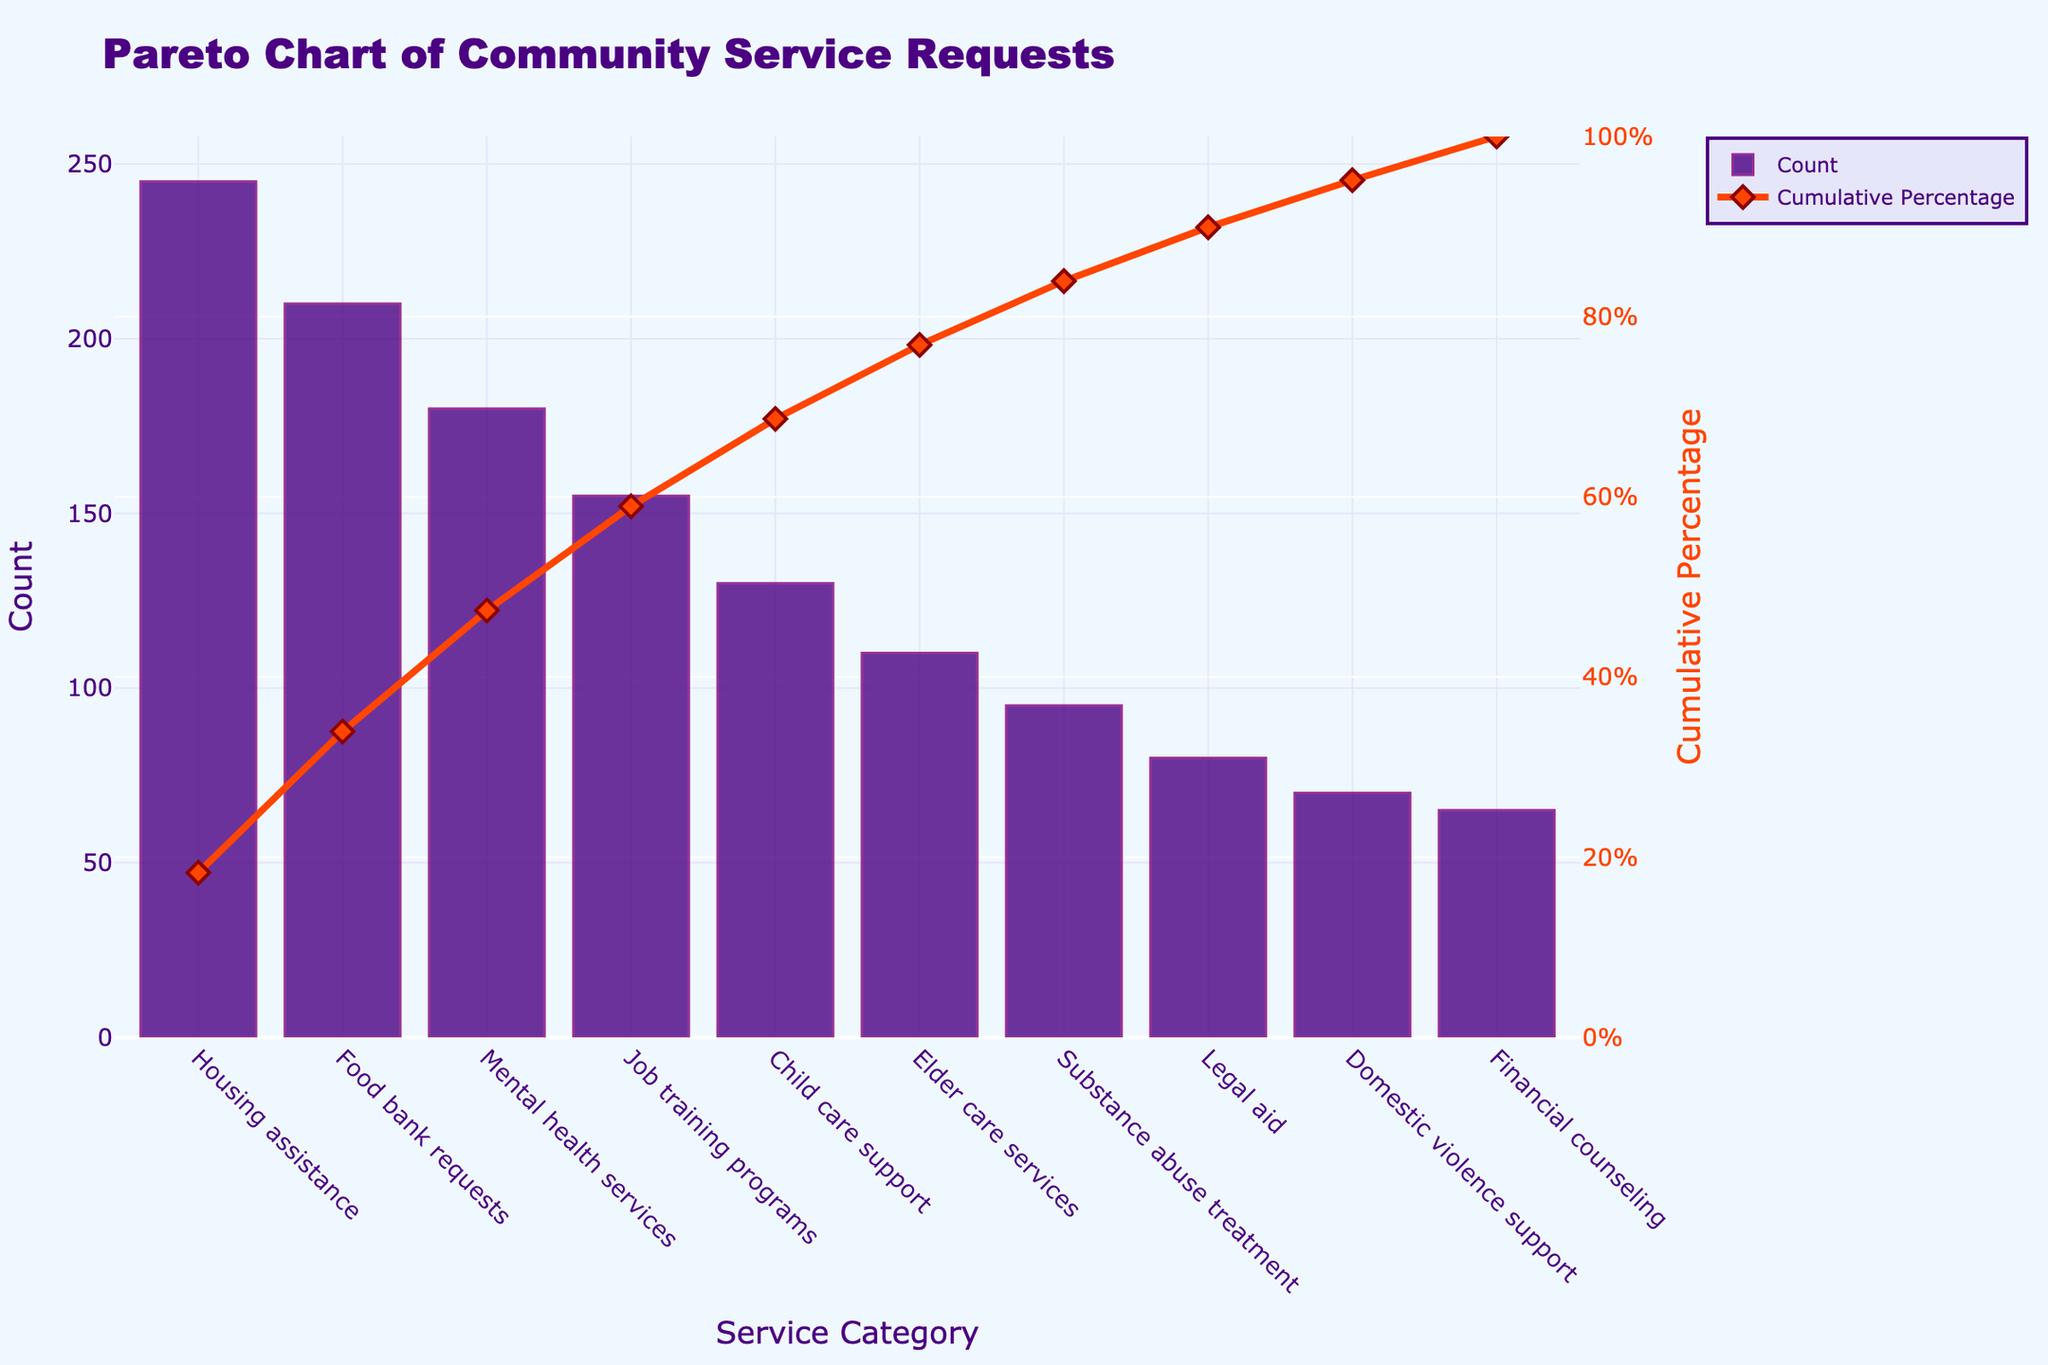What's the highest number of service requests in a single category? The highest count can be found by looking at the tallest bar in the chart, which represents "Housing assistance" with 245 requests.
Answer: 245 Which service category represents the lowest number of requests? The lowest count can be determined by identifying the shortest bar, which is for "Financial counseling" with 65 requests.
Answer: Financial counseling What is the cumulative percentage up to "Mental health services"? To find the cumulative percentage up to "Mental health services", you sum the percentages as shown on the line up to the specified category. The cumulative percentage at "Mental health services" is approximately 50%.
Answer: Approximately 50% How much higher is the request count for "Housing assistance" compared to "Food bank requests"? Subtract the count of "Food bank requests" (210) from that of "Housing assistance" (245) to find the difference: 245 - 210 = 35.
Answer: 35 Which categories together account for about 80% of the service requests? The categories together up to around 80% on the cumulative percentage line are "Housing assistance", "Food bank requests", "Mental health services", "Job training programs", "Child care support", and "Elder care services".
Answer: Housing assistance, Food bank requests, Mental health services, Job training programs, Child care support, Elder care services What is the cumulative percentage at "Child care support"? The cumulative percentage at "Child care support" can be seen on the cumulative percentage line at that category, which is approximately 74%.
Answer: Approximately 74% How many service requests are there in total for all categories? Sum all the counts from each bar in the chart: 245 + 210 + 180 + 155 + 130 + 110 + 95 + 80 + 70 + 65 = 1340.
Answer: 1340 If "Housing assistance" requests doubled, how would the cumulative percentage at "Housing assistance" change? If Housing assistance requests doubled, the count would be 245 x 2 = 490. The new total requests would be 490 + (1340 - 245) = 1585. The new cumulative percentage for Housing assistance would be 490 / 1585 * 100 ≈ 30.90%.
Answer: Approximately 30.90% Which categories fall below the 60% cumulative percentage threshold? The categories up to just before 60% on the cumulative percentage line are "Housing assistance", "Food bank requests", "Mental health services", and "Job training programs".
Answer: Housing assistance, Food bank requests, Mental health services, Job training programs What is the difference in cumulative percentage between "Job training programs" and "Elder care services"? The cumulative percentage at "Job training programs" is approximately 52%. The cumulative percentage at "Elder care services" is around 74%. The difference is 74 - 52 = 22%.
Answer: 22% 